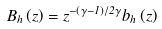<formula> <loc_0><loc_0><loc_500><loc_500>B _ { h } \left ( z \right ) = z ^ { - \left ( \gamma - 1 \right ) / 2 \gamma } b _ { h } \left ( z \right )</formula> 